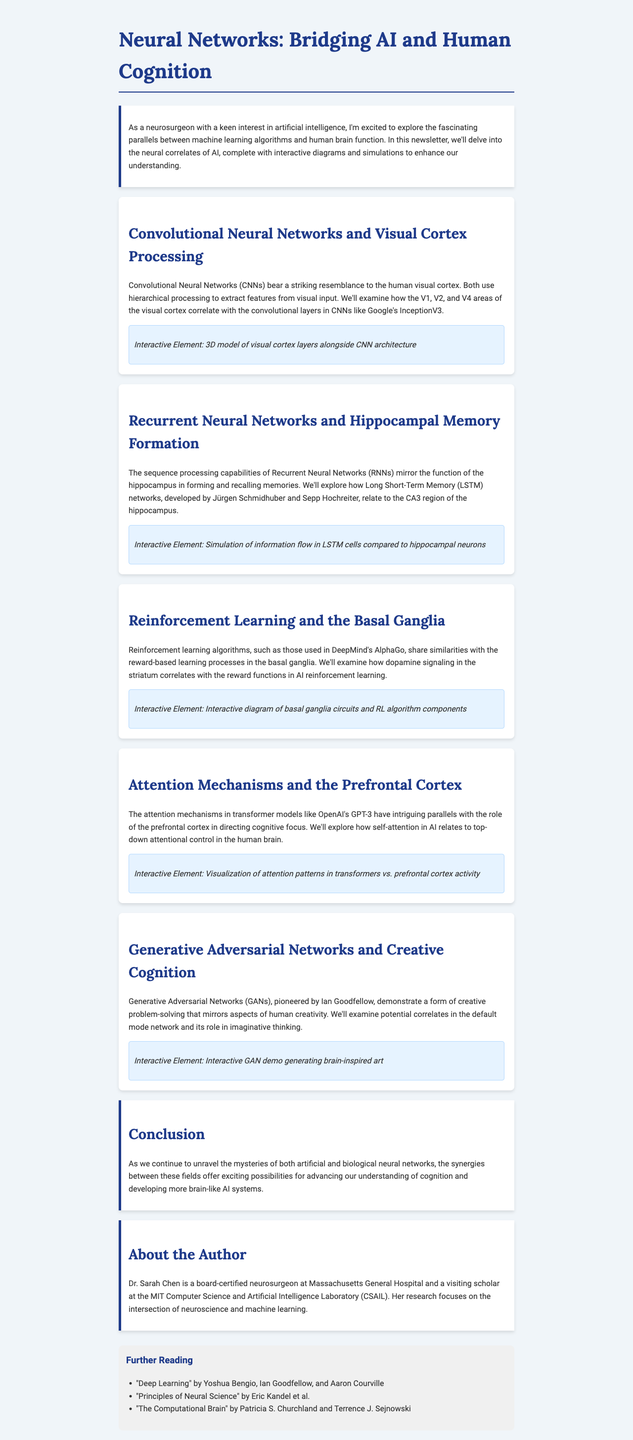What is the title of the newsletter? The title is clearly stated at the beginning of the document.
Answer: Neural Networks: Bridging AI and Human Cognition Who developed Long Short-Term Memory networks? The document mentions Jürgen Schmidhuber and Sepp Hochreiter in relation to LSTM networks.
Answer: Jürgen Schmidhuber and Sepp Hochreiter Which area of the brain is compared to CNNs? The section discusses the resemblance between CNNs and a specific part of the brain.
Answer: Visual cortex What does the interactive element about attention mechanisms compare? The document states that it compares self-attention in AI to a specific brain function.
Answer: Top-down attentional control Who is the author of the newsletter? The author's name and title are provided in the about section.
Answer: Dr. Sarah Chen What is the main focus of the newsletter? The introduction explains the primary theme explored throughout the document.
Answer: Parallels between AI and human cognition What type of networks do GANs represent? The document identifies GANs as a specific kind of network related to cognition.
Answer: Creative problem-solving What is the section on Reinforcement Learning primarily about? The document summarizes the section focusing on a specific learning process.
Answer: Reward-based learning processes 